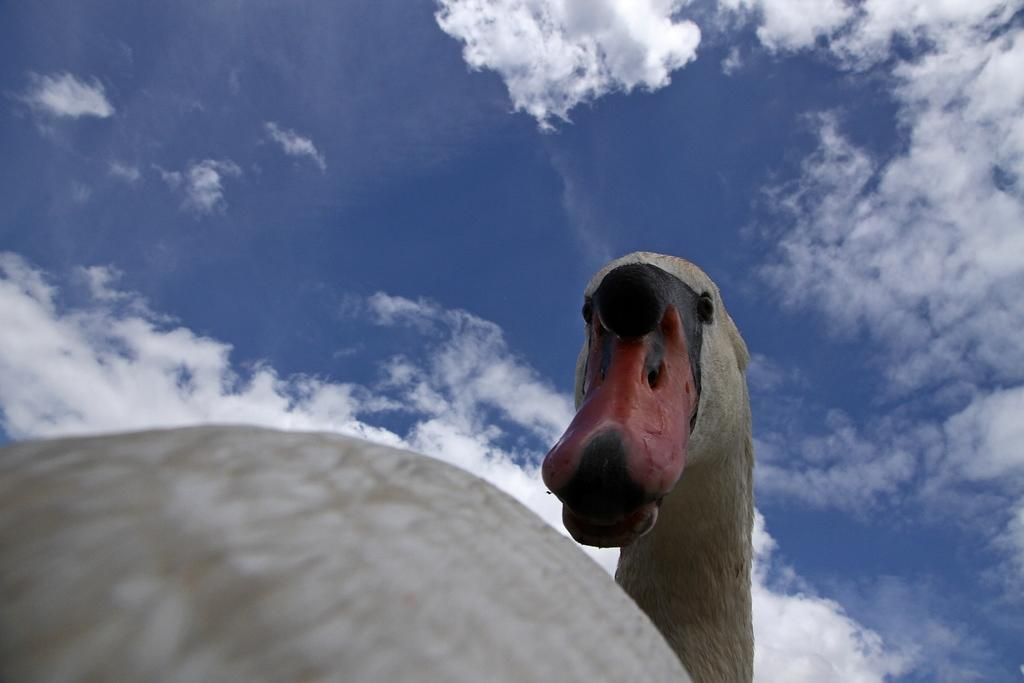What type of animal can be seen in the picture? There is a bird in the picture. What can be seen in the background of the picture? The sky is visible in the background of the picture. How many sisters does the bird have in the picture? There is no mention of sisters in the image, as it features a bird and the sky. 